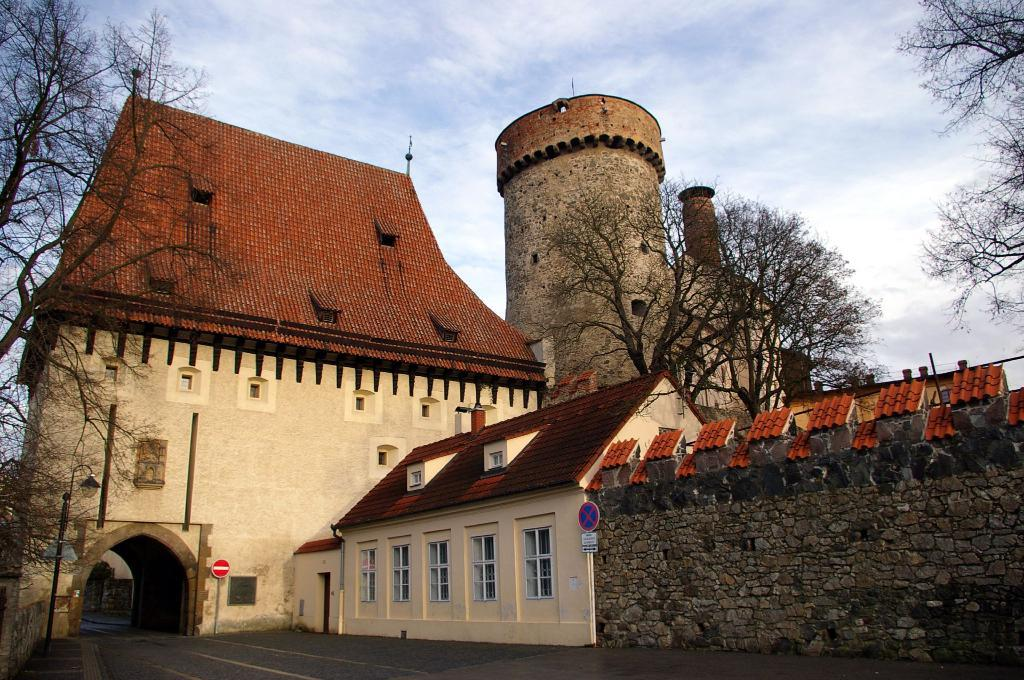What type of structure is present in the image? There is a building in the image. What other natural elements can be seen in the image? There are trees in the image. What is at the bottom of the image? There is a road at the bottom of the image. What can be seen in the background of the image? The sky is visible in the background of the image. What type of sound can be heard coming from the owl in the image? There is no owl present in the image, so it is not possible to determine what, if any, sound might be heard. 